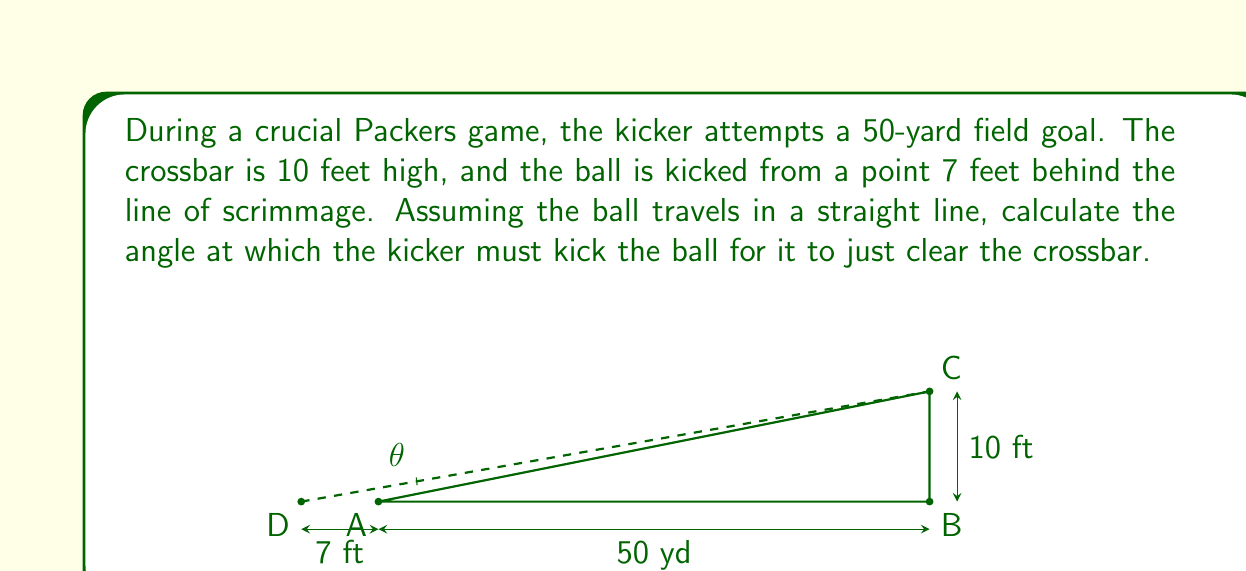Can you answer this question? Let's approach this step-by-step using trigonometry:

1) First, we need to convert all measurements to the same unit. Let's use yards:
   50 yards = 50 yards
   10 feet = 10/3 yards (since 1 yard = 3 feet)
   7 feet = 7/3 yards

2) Now, we can set up a right triangle. The base of the triangle is the distance from the kicker to the crossbar:
   Base = 50 + 7/3 = 157/3 yards

3) The height of the triangle is the height of the crossbar:
   Height = 10/3 yards

4) We can now use the tangent function to find the angle. The tangent of an angle in a right triangle is the opposite side divided by the adjacent side:

   $$\tan(\theta) = \frac{\text{opposite}}{\text{adjacent}} = \frac{\text{height}}{\text{base}}$$

5) Plugging in our values:

   $$\tan(\theta) = \frac{10/3}{157/3} = \frac{10}{157}$$

6) To find $\theta$, we need to take the inverse tangent (arctan) of both sides:

   $$\theta = \arctan(\frac{10}{157})$$

7) Using a calculator or computer:

   $$\theta \approx 3.64^\circ$$

Therefore, the kicker needs to kick the ball at an angle of approximately 3.64° for it to just clear the crossbar.
Answer: $\theta \approx 3.64^\circ$ 